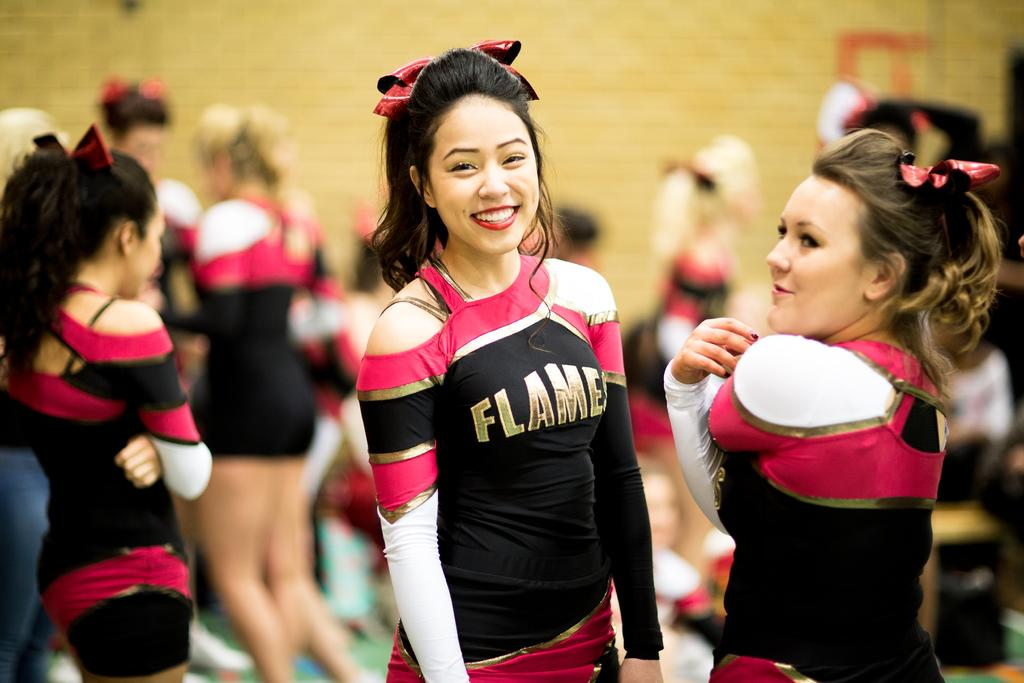<image>
Relay a brief, clear account of the picture shown. cheerleaders with one wearing a uniform that says 'flames' 